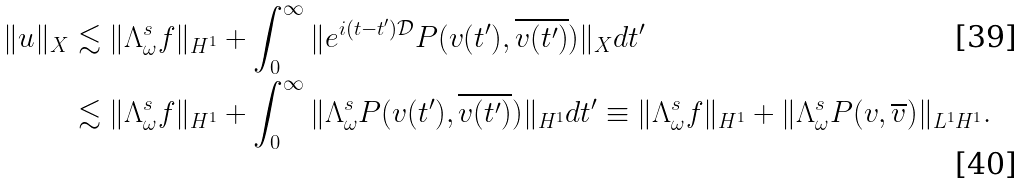<formula> <loc_0><loc_0><loc_500><loc_500>\| u \| _ { X } & \lesssim \| \Lambda ^ { s } _ { \omega } f \| _ { H ^ { 1 } } + \int _ { 0 } ^ { \infty } \| e ^ { i ( t - t ^ { \prime } ) \mathcal { D } } P ( v ( t ^ { \prime } ) , \overline { v ( t ^ { \prime } ) } ) \| _ { X } d t ^ { \prime } \\ & \lesssim \| \Lambda ^ { s } _ { \omega } f \| _ { H ^ { 1 } } + \int _ { 0 } ^ { \infty } \| \Lambda ^ { s } _ { \omega } P ( v ( t ^ { \prime } ) , \overline { v ( t ^ { \prime } ) } ) \| _ { H ^ { 1 } } d t ^ { \prime } \equiv \| \Lambda ^ { s } _ { \omega } f \| _ { H ^ { 1 } } + \| \Lambda ^ { s } _ { \omega } P ( v , \overline { v } ) \| _ { L ^ { 1 } H ^ { 1 } } .</formula> 